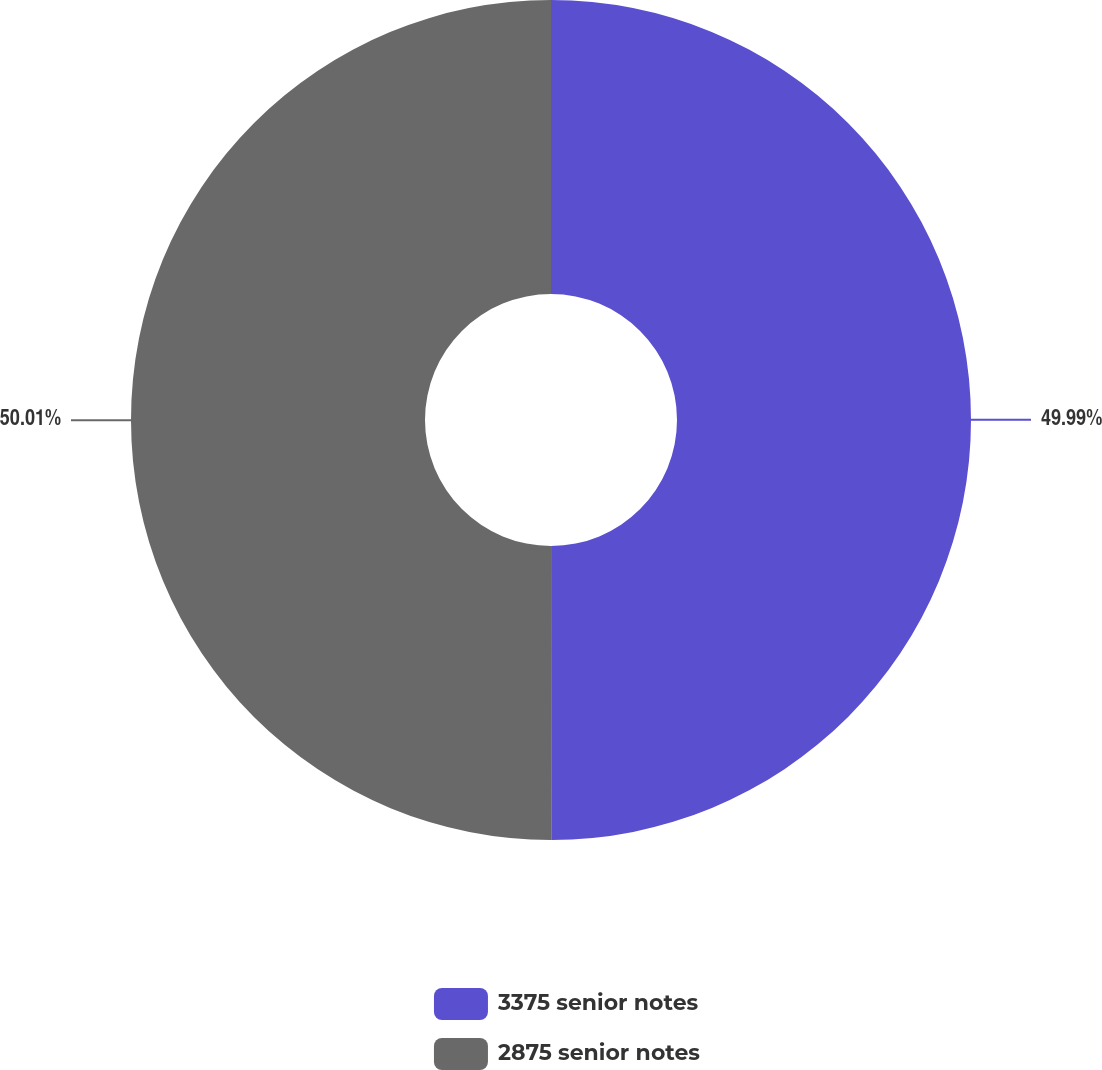Convert chart to OTSL. <chart><loc_0><loc_0><loc_500><loc_500><pie_chart><fcel>3375 senior notes<fcel>2875 senior notes<nl><fcel>49.99%<fcel>50.01%<nl></chart> 